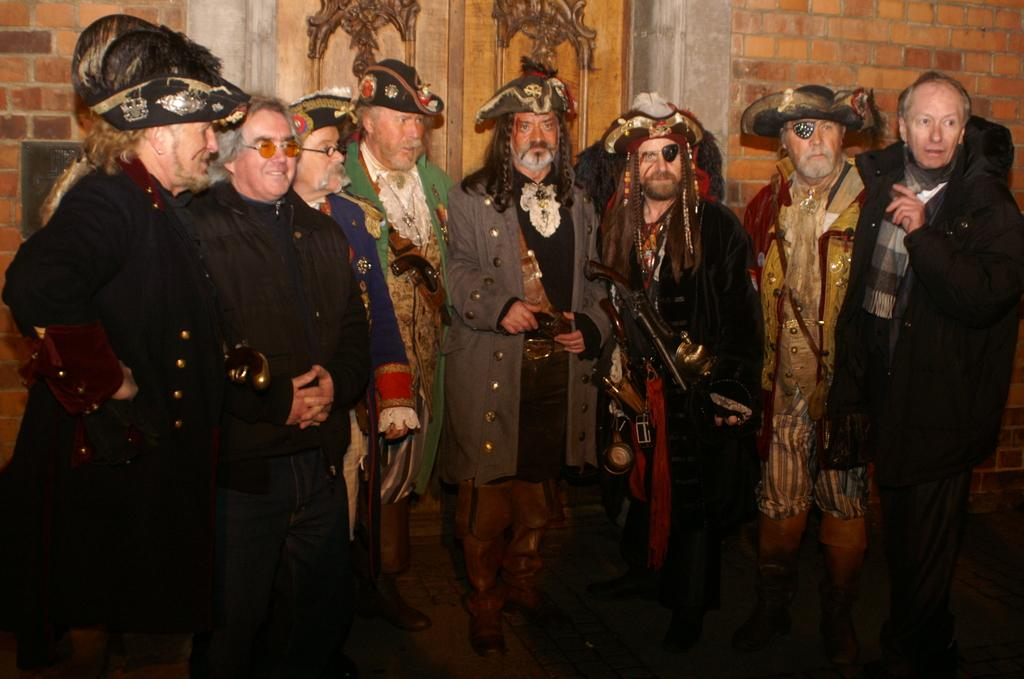What is happening in the image? There are people standing in the image. What are the people wearing? The people are wearing costumes. What can be seen in the background of the image? There is a wall in the background of the image. What type of toy can be seen in the image? There is no toy present in the image. What is the height of the wall in the background of the image? The height of the wall cannot be determined from the image. 